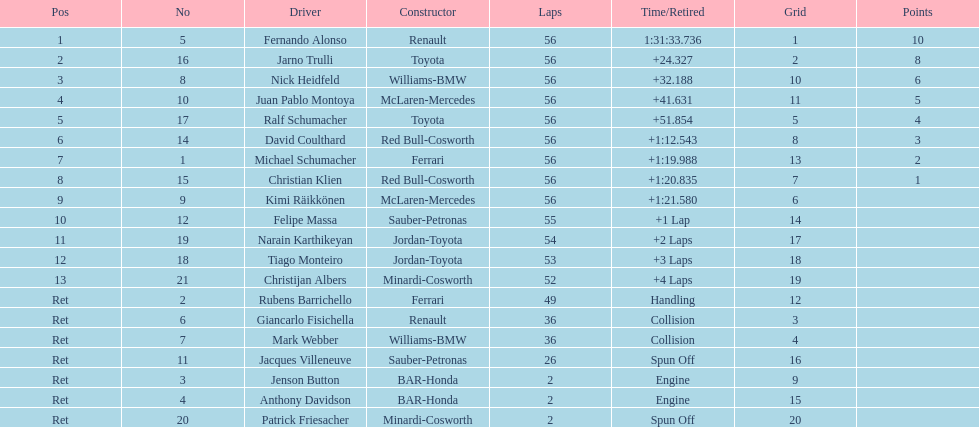Would you be able to parse every entry in this table? {'header': ['Pos', 'No', 'Driver', 'Constructor', 'Laps', 'Time/Retired', 'Grid', 'Points'], 'rows': [['1', '5', 'Fernando Alonso', 'Renault', '56', '1:31:33.736', '1', '10'], ['2', '16', 'Jarno Trulli', 'Toyota', '56', '+24.327', '2', '8'], ['3', '8', 'Nick Heidfeld', 'Williams-BMW', '56', '+32.188', '10', '6'], ['4', '10', 'Juan Pablo Montoya', 'McLaren-Mercedes', '56', '+41.631', '11', '5'], ['5', '17', 'Ralf Schumacher', 'Toyota', '56', '+51.854', '5', '4'], ['6', '14', 'David Coulthard', 'Red Bull-Cosworth', '56', '+1:12.543', '8', '3'], ['7', '1', 'Michael Schumacher', 'Ferrari', '56', '+1:19.988', '13', '2'], ['8', '15', 'Christian Klien', 'Red Bull-Cosworth', '56', '+1:20.835', '7', '1'], ['9', '9', 'Kimi Räikkönen', 'McLaren-Mercedes', '56', '+1:21.580', '6', ''], ['10', '12', 'Felipe Massa', 'Sauber-Petronas', '55', '+1 Lap', '14', ''], ['11', '19', 'Narain Karthikeyan', 'Jordan-Toyota', '54', '+2 Laps', '17', ''], ['12', '18', 'Tiago Monteiro', 'Jordan-Toyota', '53', '+3 Laps', '18', ''], ['13', '21', 'Christijan Albers', 'Minardi-Cosworth', '52', '+4 Laps', '19', ''], ['Ret', '2', 'Rubens Barrichello', 'Ferrari', '49', 'Handling', '12', ''], ['Ret', '6', 'Giancarlo Fisichella', 'Renault', '36', 'Collision', '3', ''], ['Ret', '7', 'Mark Webber', 'Williams-BMW', '36', 'Collision', '4', ''], ['Ret', '11', 'Jacques Villeneuve', 'Sauber-Petronas', '26', 'Spun Off', '16', ''], ['Ret', '3', 'Jenson Button', 'BAR-Honda', '2', 'Engine', '9', ''], ['Ret', '4', 'Anthony Davidson', 'BAR-Honda', '2', 'Engine', '15', ''], ['Ret', '20', 'Patrick Friesacher', 'Minardi-Cosworth', '2', 'Spun Off', '20', '']]} Which driver completed first? Fernando Alonso. 